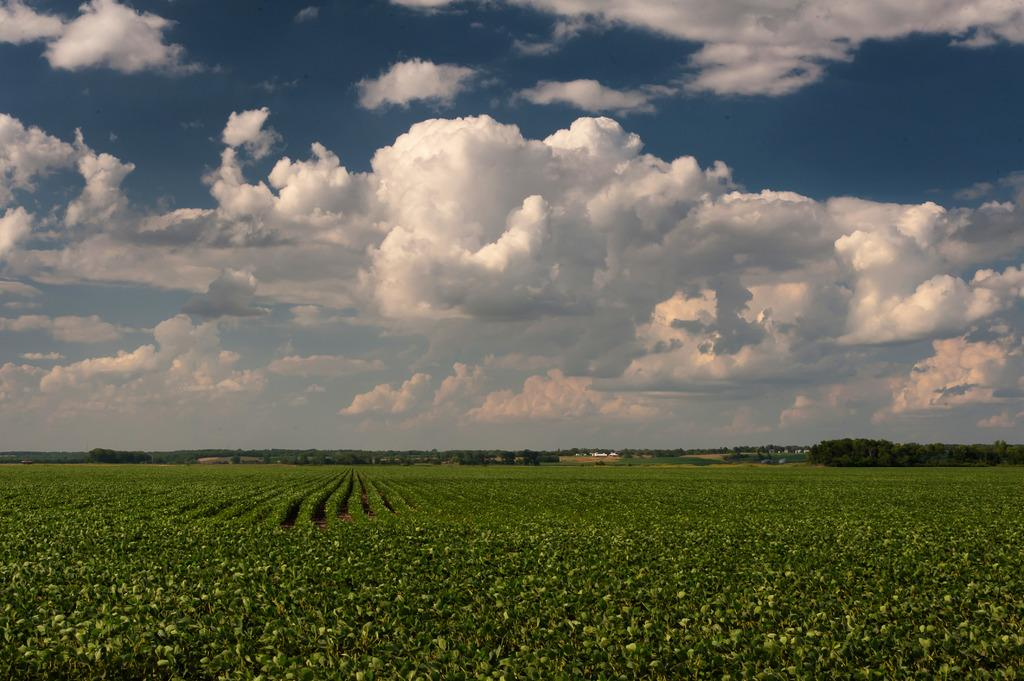What type of vegetation can be seen in the foreground of the image? There is greenery in the foreground of the image. What type of structures are visible in the image? The image appears to contain houses. What other natural elements can be seen in the image? There are trees visible in the image. What is visible in the background of the image? The sky is visible in the background of the image. Where is the volcano located in the image? There is no volcano present in the image. What type of fabric is draped over the trees in the image? There is no fabric or scarf draped over the trees in the image; only greenery, houses, trees, and the sky are present. 